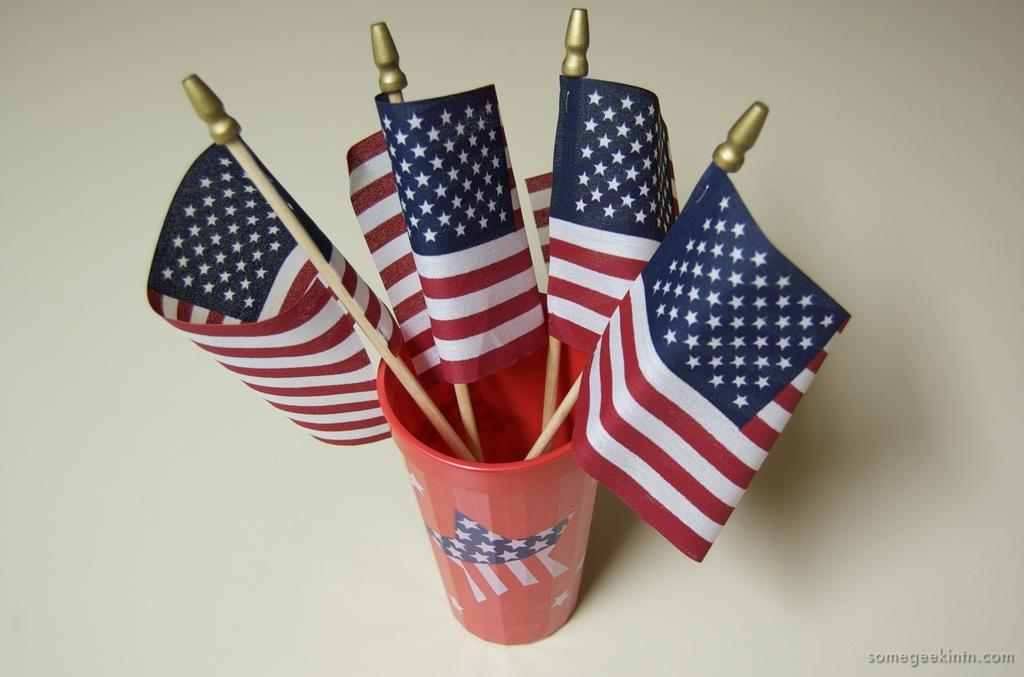What object in the image is typically used for drinking? There is a glass in the image, which is typically used for drinking. What other items can be seen in the image? There are flags in the image. What type of humor can be seen in the image? There is no humor present in the image; it features a glass and flags. What is the weight of the glass in the image? The weight of the glass cannot be determined from the image alone. 